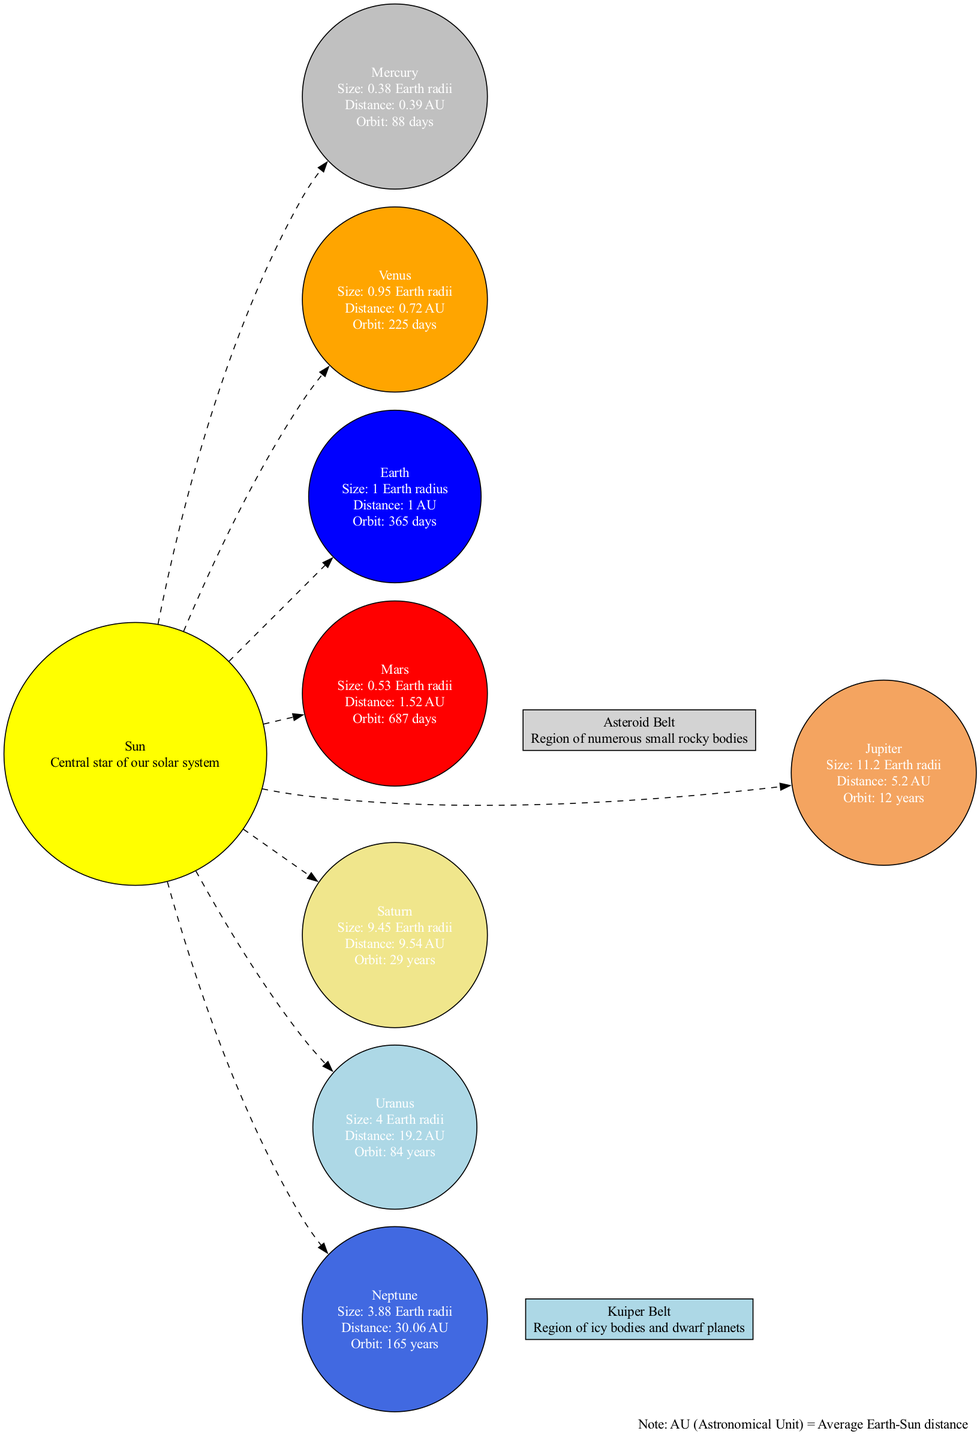What is the size of Jupiter? Jupiter's size is stated as "11.2 Earth radii" in the diagram. This information is directly visible from the label provided on Jupiter in the diagram.
Answer: 11.2 Earth radii Which planet has the shortest orbital period? The diagram indicates the orbital periods of the planets, and Mercury has an orbital period of "88 days," which is the shortest among all the planets listed.
Answer: 88 days How far is Neptune from the Sun? In the diagram, Neptune's distance from the Sun is listed as "30.06 AU," which is a direct piece of information provided in its label.
Answer: 30.06 AU Which planet is located between Mars and Jupiter? The diagram includes a node labeled "Asteroid Belt," which is explicitly described as being "Between Mars and Jupiter." This can be clearly inferred from the positioning of the nodes in the diagram.
Answer: Asteroid Belt What is the orbital period of Saturn? According to the diagram, Saturn has an orbital period labeled as "29 years," which can be found in its respective node.
Answer: 29 years Which planet is the largest in the solar system? The diagram shows that Jupiter, listed with the size of "11.2 Earth radii," is much larger than all other planets, confirming it as the largest in the solar system.
Answer: Jupiter How many planets are there in the diagram? The diagram lists a total of 8 planets under the planets section, as shown in the data provided.
Answer: 8 planets What color represents Venus in the diagram? The diagram acknowledges Venus with the color "orange," which is specified in the planet color section of the node.
Answer: Orange Where is the Kuiper Belt located? The Kuiper Belt is described in the diagram as being "Beyond Neptune," which can be directly understood from the text in its node.
Answer: Beyond Neptune 